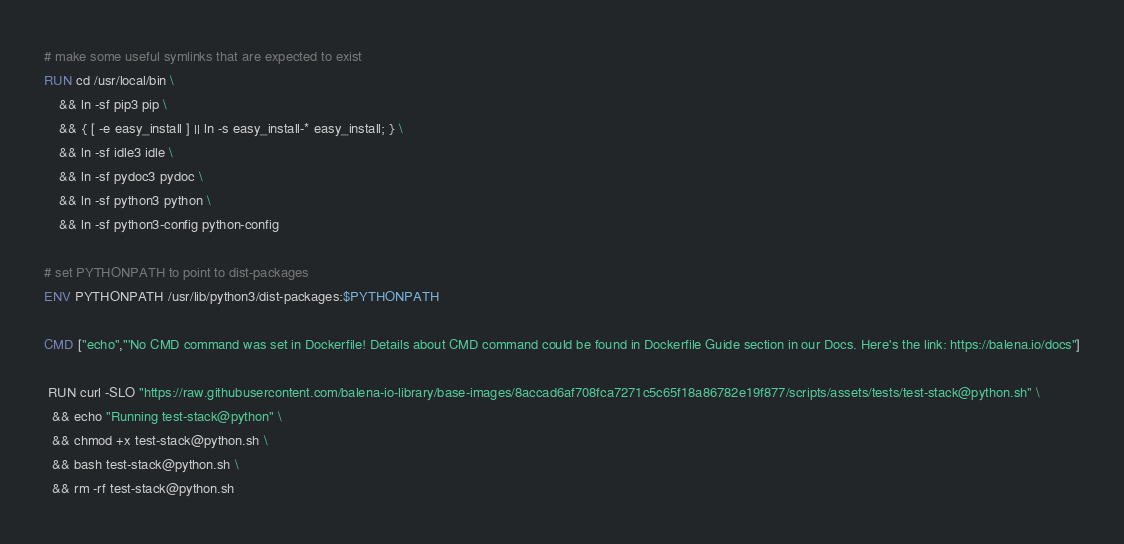<code> <loc_0><loc_0><loc_500><loc_500><_Dockerfile_>
# make some useful symlinks that are expected to exist
RUN cd /usr/local/bin \
	&& ln -sf pip3 pip \
	&& { [ -e easy_install ] || ln -s easy_install-* easy_install; } \
	&& ln -sf idle3 idle \
	&& ln -sf pydoc3 pydoc \
	&& ln -sf python3 python \
	&& ln -sf python3-config python-config

# set PYTHONPATH to point to dist-packages
ENV PYTHONPATH /usr/lib/python3/dist-packages:$PYTHONPATH

CMD ["echo","'No CMD command was set in Dockerfile! Details about CMD command could be found in Dockerfile Guide section in our Docs. Here's the link: https://balena.io/docs"]

 RUN curl -SLO "https://raw.githubusercontent.com/balena-io-library/base-images/8accad6af708fca7271c5c65f18a86782e19f877/scripts/assets/tests/test-stack@python.sh" \
  && echo "Running test-stack@python" \
  && chmod +x test-stack@python.sh \
  && bash test-stack@python.sh \
  && rm -rf test-stack@python.sh 
</code> 